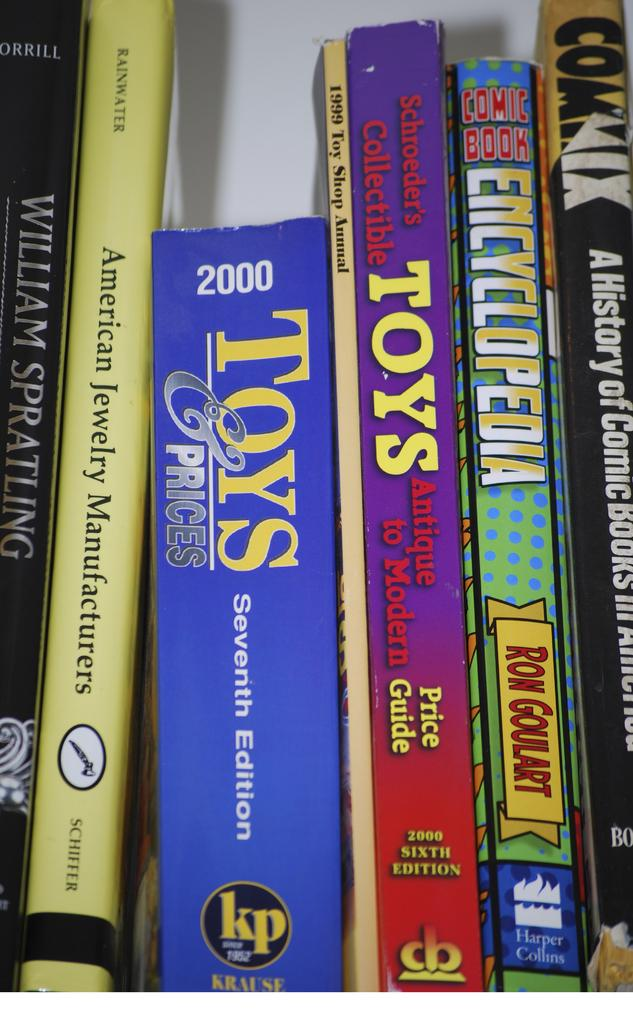<image>
Give a short and clear explanation of the subsequent image. Six spines of books are seen close up including one on toys and prices, a comic book encyclopedia and another concering American Jewelry Manufacturers. 